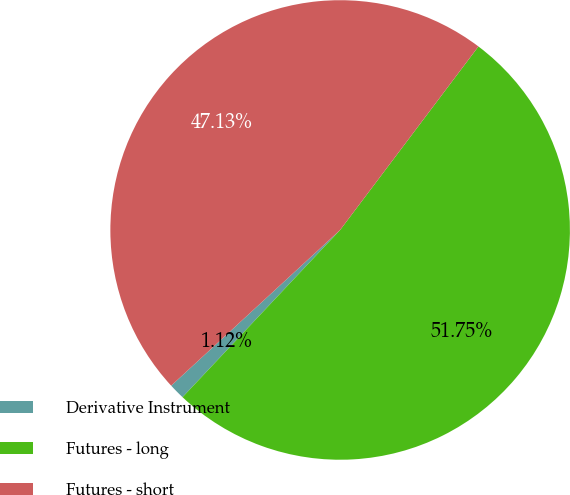Convert chart. <chart><loc_0><loc_0><loc_500><loc_500><pie_chart><fcel>Derivative Instrument<fcel>Futures - long<fcel>Futures - short<nl><fcel>1.12%<fcel>51.75%<fcel>47.13%<nl></chart> 